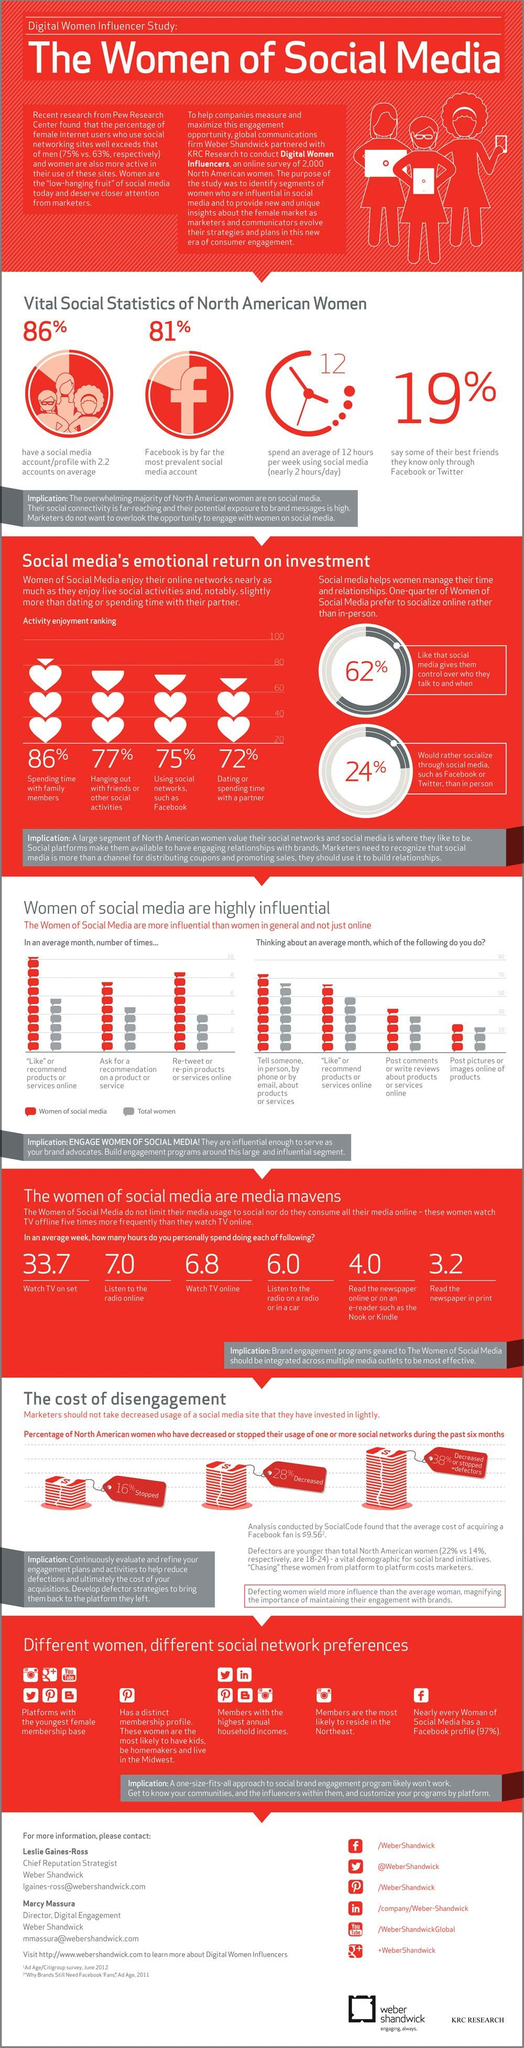Give some essential details in this illustration. In a typical week, women spend an average of 4 hours reading the newspaper online. According to the data, women typically spend an average of 3.2 hours per week reading a printed newspaper. According to data, only 14% of North American women have no social media account, while the average number of social media accounts per woman is 2.2. In one week, the average amount of time that women spend watching TV on a set is 33.7 hours. In a typical week, women spend an average of 6.8 hours watching TV online. 